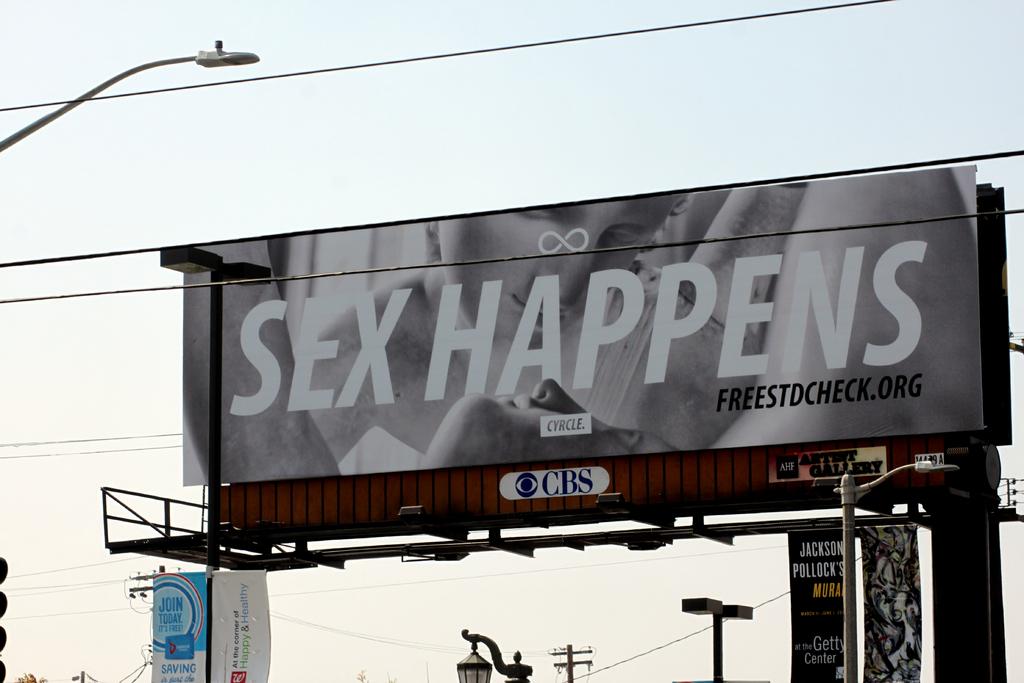What happens on the billboard?
Your answer should be very brief. Sex. 